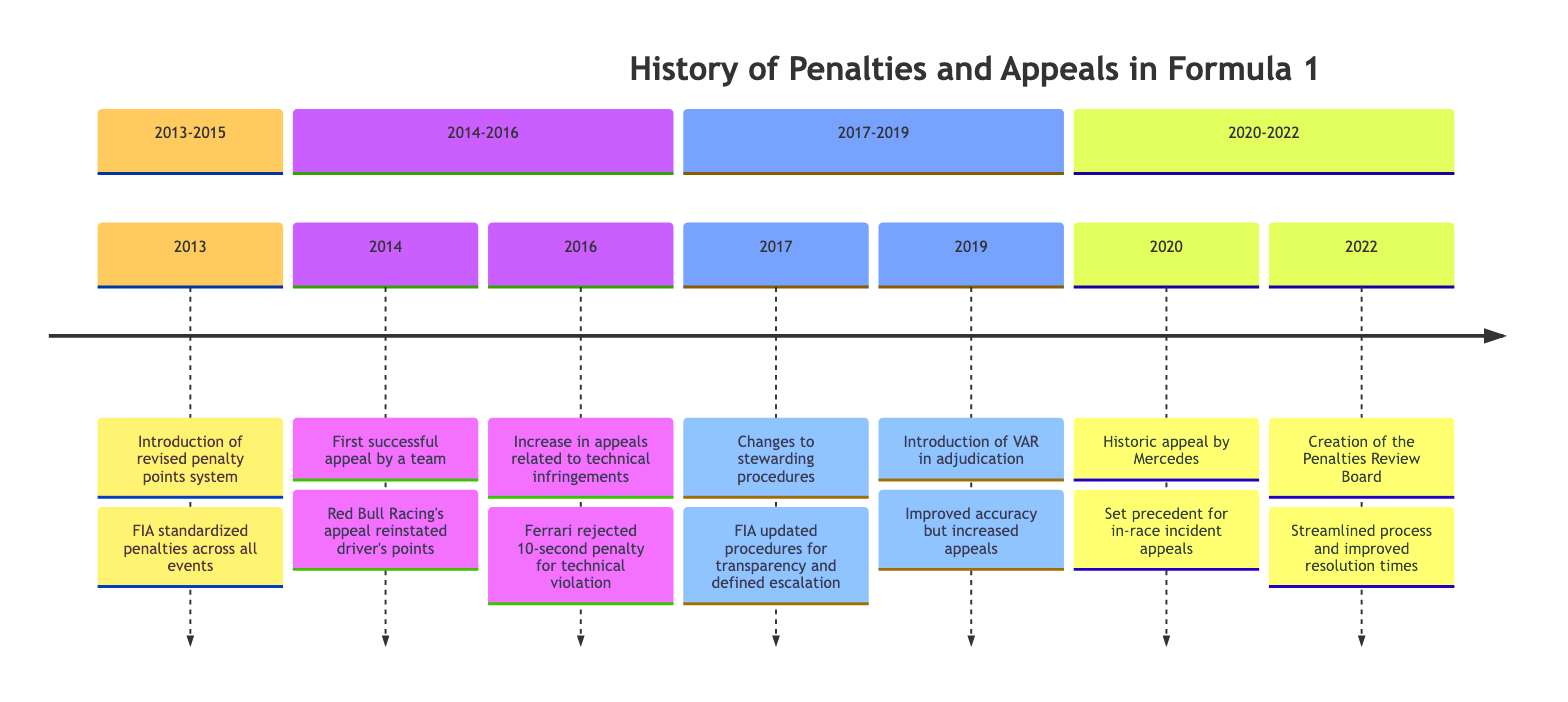What year was the revised penalty points system introduced? The diagram indicates that the revised penalty points system was introduced in 2013, as shown in the first section of the timeline.
Answer: 2013 What event marked the first successful appeal by a team? According to the timeline, the first successful appeal by a team occurred in 2014, involving Red Bull Racing who appealed a disqualification penalty.
Answer: First successful appeal by a team In what year did Mercedes make a historic appeal? The timeline shows that Mercedes made a historic appeal in 2020, which is specifically noted in the section for that year.
Answer: 2020 Which team had a notable appeal rejecting a technical violation penalty in 2016? The 2016 entry in the timeline mentions that Ferrari had a notable appeal regarding a rejected 10-second penalty for a technical violation.
Answer: Ferrari What was established in 2022 to handle complex appeals? The timeline indicates that the creation of the Penalties Review Board in 2022 was established to handle complex appeals.
Answer: Penalties Review Board How did the introduction of VAR in 2019 impact appeals? From the timeline, it can be inferred that the introduction of VAR significantly improved accuracy in adjudication but led to an increase in appeals, which is specified in the 2019 section.
Answer: Improved accuracy but increased appeals What significant change occurred in 2017 regarding stewarding procedures? The diagram highlights that in 2017, FIA updated stewarding procedures for more transparency and also to define the escalation process for penalty appeals, as noted in that year's section.
Answer: Changes to stewarding procedures How many notable events are recorded in the timeline between 2013 and 2015? By counting the events listed in the timeline, there are three notable events from 2013 to 2015, which include the introduction of the revised penalty points system and the first successful appeal by a team.
Answer: 3 What was the impact of the creation of the Penalties Review Board on resolution times? The timeline specifically mentions that the creation of the Penalties Review Board in 2022 streamlined the appeal process and improved resolution times, indicating a positive impact on efficiency.
Answer: Improved resolution times 